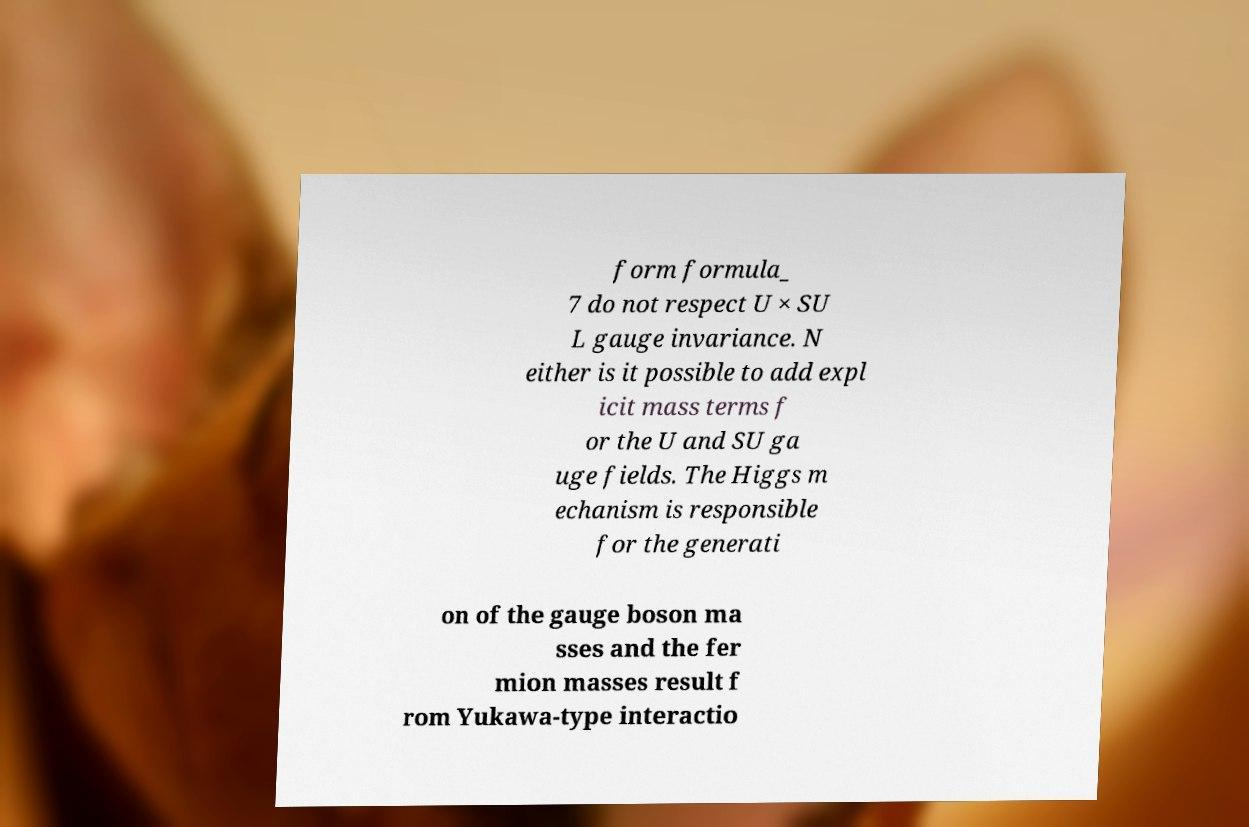I need the written content from this picture converted into text. Can you do that? form formula_ 7 do not respect U × SU L gauge invariance. N either is it possible to add expl icit mass terms f or the U and SU ga uge fields. The Higgs m echanism is responsible for the generati on of the gauge boson ma sses and the fer mion masses result f rom Yukawa-type interactio 